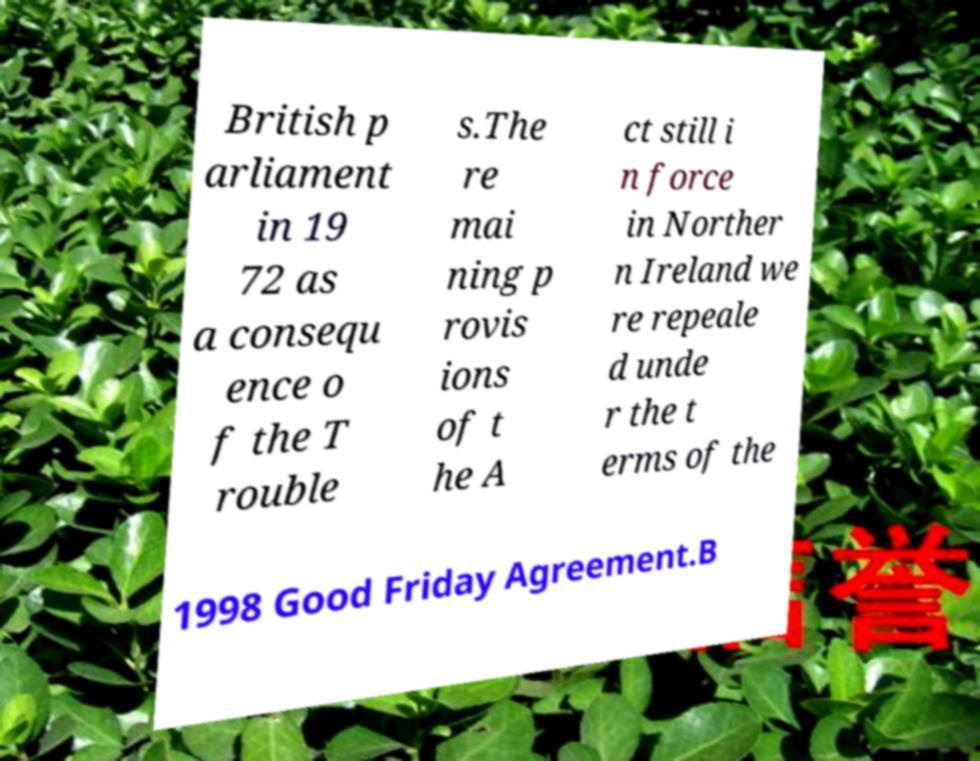Could you assist in decoding the text presented in this image and type it out clearly? British p arliament in 19 72 as a consequ ence o f the T rouble s.The re mai ning p rovis ions of t he A ct still i n force in Norther n Ireland we re repeale d unde r the t erms of the 1998 Good Friday Agreement.B 